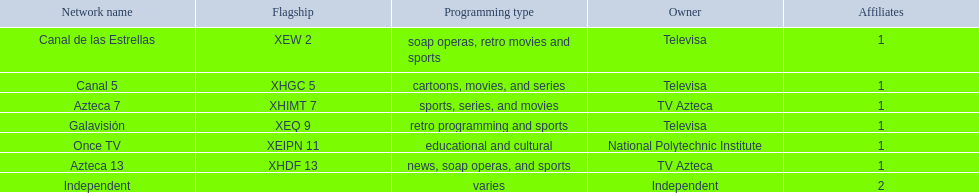What television stations are in morelos? Canal de las Estrellas, Canal 5, Azteca 7, Galavisión, Once TV, Azteca 13, Independent. Of those which network is owned by national polytechnic institute? Once TV. 